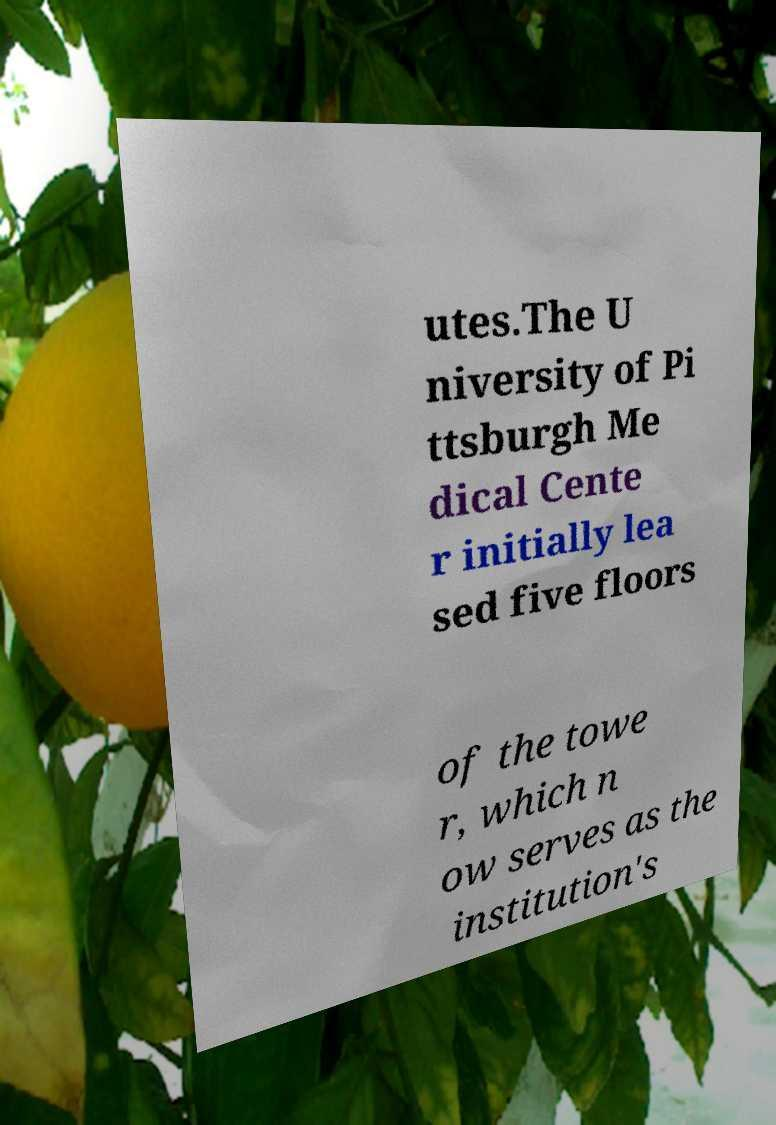Please identify and transcribe the text found in this image. utes.The U niversity of Pi ttsburgh Me dical Cente r initially lea sed five floors of the towe r, which n ow serves as the institution's 